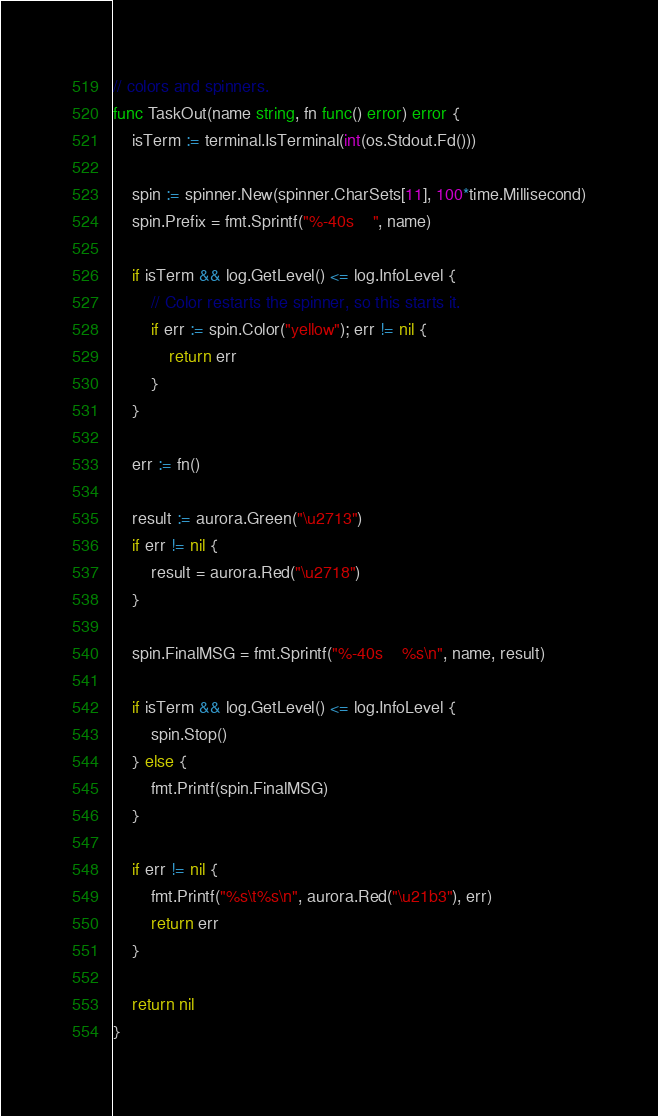Convert code to text. <code><loc_0><loc_0><loc_500><loc_500><_Go_>// colors and spinners.
func TaskOut(name string, fn func() error) error {
	isTerm := terminal.IsTerminal(int(os.Stdout.Fd()))

	spin := spinner.New(spinner.CharSets[11], 100*time.Millisecond)
	spin.Prefix = fmt.Sprintf("%-40s    ", name)

	if isTerm && log.GetLevel() <= log.InfoLevel {
		// Color restarts the spinner, so this starts it.
		if err := spin.Color("yellow"); err != nil {
			return err
		}
	}

	err := fn()

	result := aurora.Green("\u2713")
	if err != nil {
		result = aurora.Red("\u2718")
	}

	spin.FinalMSG = fmt.Sprintf("%-40s    %s\n", name, result)

	if isTerm && log.GetLevel() <= log.InfoLevel {
		spin.Stop()
	} else {
		fmt.Printf(spin.FinalMSG)
	}

	if err != nil {
		fmt.Printf("%s\t%s\n", aurora.Red("\u21b3"), err)
		return err
	}

	return nil
}
</code> 